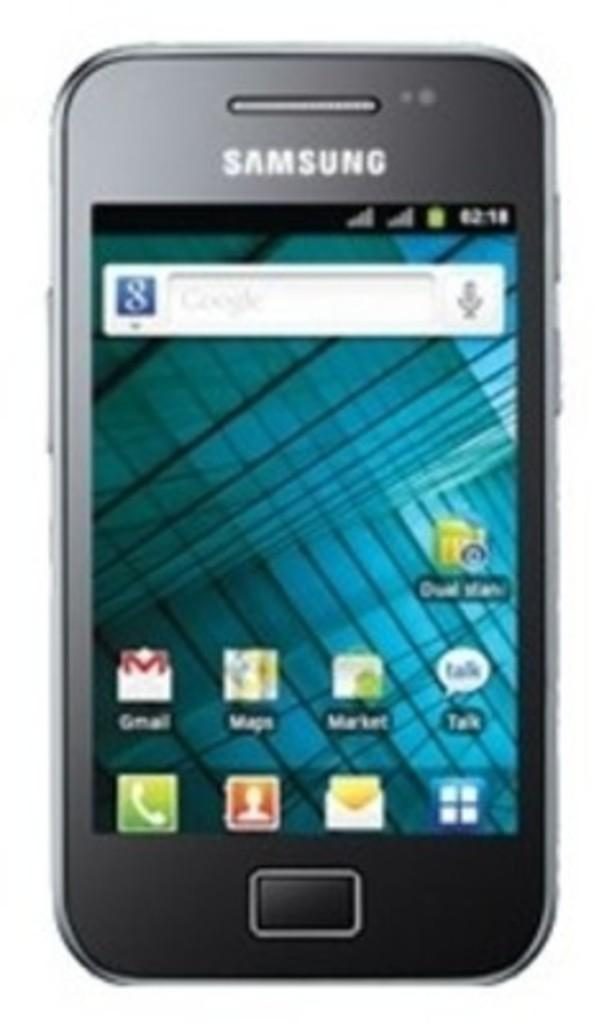<image>
Render a clear and concise summary of the photo. A Samsung smartphone in black on a main page. 